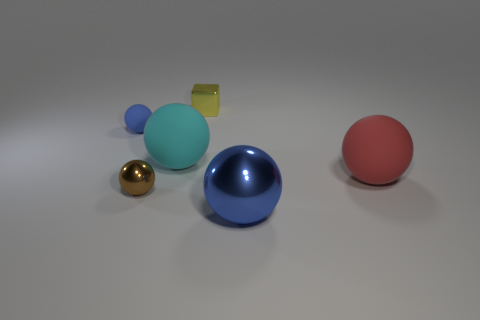Do the rubber ball on the left side of the large cyan rubber object and the metallic thing on the right side of the yellow metallic thing have the same size?
Your answer should be compact. No. What number of other small matte objects are the same color as the tiny matte object?
Offer a terse response. 0. How many tiny objects are brown metal balls or red rubber spheres?
Offer a very short reply. 1. Does the blue object that is to the left of the big cyan rubber ball have the same material as the yellow block?
Your answer should be compact. No. There is a tiny object that is behind the tiny blue rubber sphere; what color is it?
Offer a very short reply. Yellow. Are there any other yellow metallic cubes that have the same size as the yellow block?
Offer a very short reply. No. There is a red ball that is the same size as the blue metal thing; what is it made of?
Provide a succinct answer. Rubber. Is the size of the red rubber ball the same as the brown object that is in front of the small cube?
Your answer should be compact. No. There is a blue ball that is left of the yellow shiny cube; what is it made of?
Give a very brief answer. Rubber. Are there an equal number of brown things that are behind the large red thing and tiny blue spheres?
Make the answer very short. No. 